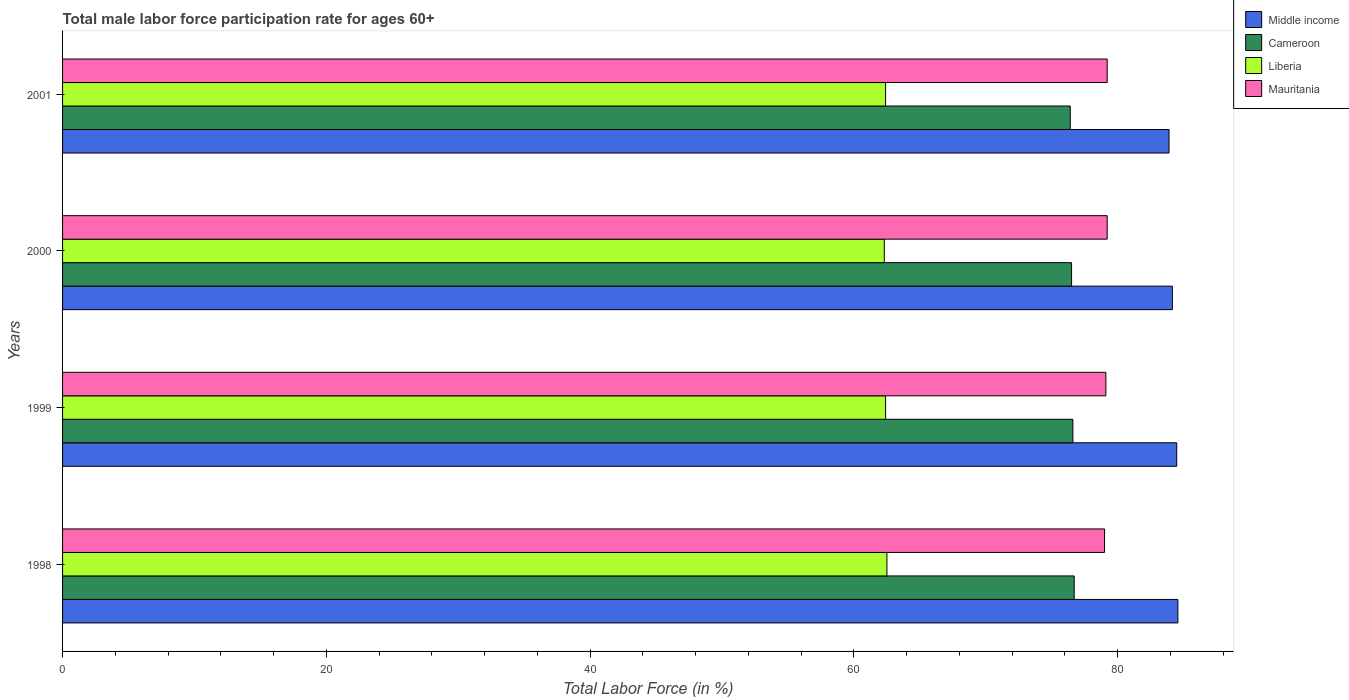Are the number of bars per tick equal to the number of legend labels?
Your answer should be very brief. Yes. What is the label of the 2nd group of bars from the top?
Your answer should be compact. 2000. What is the male labor force participation rate in Cameroon in 1999?
Make the answer very short. 76.6. Across all years, what is the maximum male labor force participation rate in Cameroon?
Your answer should be very brief. 76.7. Across all years, what is the minimum male labor force participation rate in Cameroon?
Provide a succinct answer. 76.4. In which year was the male labor force participation rate in Middle income maximum?
Your answer should be very brief. 1998. In which year was the male labor force participation rate in Middle income minimum?
Make the answer very short. 2001. What is the total male labor force participation rate in Middle income in the graph?
Give a very brief answer. 337.07. What is the difference between the male labor force participation rate in Liberia in 1998 and that in 2000?
Your answer should be very brief. 0.2. What is the difference between the male labor force participation rate in Middle income in 2000 and the male labor force participation rate in Mauritania in 1999?
Provide a succinct answer. 5.04. What is the average male labor force participation rate in Mauritania per year?
Provide a succinct answer. 79.12. In the year 1998, what is the difference between the male labor force participation rate in Liberia and male labor force participation rate in Cameroon?
Offer a very short reply. -14.2. In how many years, is the male labor force participation rate in Middle income greater than 20 %?
Give a very brief answer. 4. What is the ratio of the male labor force participation rate in Liberia in 1998 to that in 2000?
Ensure brevity in your answer.  1. What is the difference between the highest and the second highest male labor force participation rate in Cameroon?
Your answer should be compact. 0.1. What is the difference between the highest and the lowest male labor force participation rate in Mauritania?
Your answer should be compact. 0.2. Is it the case that in every year, the sum of the male labor force participation rate in Cameroon and male labor force participation rate in Middle income is greater than the sum of male labor force participation rate in Mauritania and male labor force participation rate in Liberia?
Give a very brief answer. Yes. What does the 2nd bar from the bottom in 1998 represents?
Your answer should be compact. Cameroon. Is it the case that in every year, the sum of the male labor force participation rate in Liberia and male labor force participation rate in Cameroon is greater than the male labor force participation rate in Middle income?
Your answer should be compact. Yes. How many bars are there?
Give a very brief answer. 16. Are all the bars in the graph horizontal?
Keep it short and to the point. Yes. How many years are there in the graph?
Your response must be concise. 4. What is the difference between two consecutive major ticks on the X-axis?
Provide a short and direct response. 20. Does the graph contain any zero values?
Provide a short and direct response. No. Does the graph contain grids?
Your answer should be compact. No. How many legend labels are there?
Ensure brevity in your answer.  4. What is the title of the graph?
Provide a succinct answer. Total male labor force participation rate for ages 60+. What is the label or title of the X-axis?
Offer a terse response. Total Labor Force (in %). What is the label or title of the Y-axis?
Keep it short and to the point. Years. What is the Total Labor Force (in %) of Middle income in 1998?
Offer a very short reply. 84.56. What is the Total Labor Force (in %) in Cameroon in 1998?
Ensure brevity in your answer.  76.7. What is the Total Labor Force (in %) of Liberia in 1998?
Offer a very short reply. 62.5. What is the Total Labor Force (in %) of Mauritania in 1998?
Your response must be concise. 79. What is the Total Labor Force (in %) in Middle income in 1999?
Offer a very short reply. 84.47. What is the Total Labor Force (in %) of Cameroon in 1999?
Keep it short and to the point. 76.6. What is the Total Labor Force (in %) in Liberia in 1999?
Keep it short and to the point. 62.4. What is the Total Labor Force (in %) of Mauritania in 1999?
Your response must be concise. 79.1. What is the Total Labor Force (in %) in Middle income in 2000?
Provide a short and direct response. 84.14. What is the Total Labor Force (in %) of Cameroon in 2000?
Offer a terse response. 76.5. What is the Total Labor Force (in %) in Liberia in 2000?
Your answer should be compact. 62.3. What is the Total Labor Force (in %) of Mauritania in 2000?
Provide a short and direct response. 79.2. What is the Total Labor Force (in %) in Middle income in 2001?
Ensure brevity in your answer.  83.89. What is the Total Labor Force (in %) of Cameroon in 2001?
Ensure brevity in your answer.  76.4. What is the Total Labor Force (in %) of Liberia in 2001?
Offer a terse response. 62.4. What is the Total Labor Force (in %) of Mauritania in 2001?
Keep it short and to the point. 79.2. Across all years, what is the maximum Total Labor Force (in %) in Middle income?
Your answer should be very brief. 84.56. Across all years, what is the maximum Total Labor Force (in %) of Cameroon?
Your answer should be compact. 76.7. Across all years, what is the maximum Total Labor Force (in %) in Liberia?
Offer a very short reply. 62.5. Across all years, what is the maximum Total Labor Force (in %) of Mauritania?
Ensure brevity in your answer.  79.2. Across all years, what is the minimum Total Labor Force (in %) in Middle income?
Keep it short and to the point. 83.89. Across all years, what is the minimum Total Labor Force (in %) in Cameroon?
Provide a short and direct response. 76.4. Across all years, what is the minimum Total Labor Force (in %) of Liberia?
Give a very brief answer. 62.3. Across all years, what is the minimum Total Labor Force (in %) in Mauritania?
Offer a very short reply. 79. What is the total Total Labor Force (in %) in Middle income in the graph?
Your answer should be compact. 337.07. What is the total Total Labor Force (in %) of Cameroon in the graph?
Provide a succinct answer. 306.2. What is the total Total Labor Force (in %) in Liberia in the graph?
Make the answer very short. 249.6. What is the total Total Labor Force (in %) in Mauritania in the graph?
Keep it short and to the point. 316.5. What is the difference between the Total Labor Force (in %) in Middle income in 1998 and that in 1999?
Your answer should be very brief. 0.09. What is the difference between the Total Labor Force (in %) in Cameroon in 1998 and that in 1999?
Give a very brief answer. 0.1. What is the difference between the Total Labor Force (in %) of Middle income in 1998 and that in 2000?
Ensure brevity in your answer.  0.42. What is the difference between the Total Labor Force (in %) in Cameroon in 1998 and that in 2000?
Your answer should be very brief. 0.2. What is the difference between the Total Labor Force (in %) of Middle income in 1998 and that in 2001?
Your answer should be compact. 0.67. What is the difference between the Total Labor Force (in %) in Liberia in 1998 and that in 2001?
Offer a terse response. 0.1. What is the difference between the Total Labor Force (in %) in Mauritania in 1998 and that in 2001?
Your response must be concise. -0.2. What is the difference between the Total Labor Force (in %) of Middle income in 1999 and that in 2000?
Make the answer very short. 0.33. What is the difference between the Total Labor Force (in %) of Middle income in 1999 and that in 2001?
Provide a succinct answer. 0.58. What is the difference between the Total Labor Force (in %) in Cameroon in 1999 and that in 2001?
Your response must be concise. 0.2. What is the difference between the Total Labor Force (in %) of Liberia in 1999 and that in 2001?
Give a very brief answer. 0. What is the difference between the Total Labor Force (in %) in Mauritania in 1999 and that in 2001?
Provide a short and direct response. -0.1. What is the difference between the Total Labor Force (in %) of Middle income in 2000 and that in 2001?
Give a very brief answer. 0.25. What is the difference between the Total Labor Force (in %) in Liberia in 2000 and that in 2001?
Your response must be concise. -0.1. What is the difference between the Total Labor Force (in %) of Mauritania in 2000 and that in 2001?
Your answer should be compact. 0. What is the difference between the Total Labor Force (in %) in Middle income in 1998 and the Total Labor Force (in %) in Cameroon in 1999?
Give a very brief answer. 7.96. What is the difference between the Total Labor Force (in %) of Middle income in 1998 and the Total Labor Force (in %) of Liberia in 1999?
Provide a short and direct response. 22.16. What is the difference between the Total Labor Force (in %) in Middle income in 1998 and the Total Labor Force (in %) in Mauritania in 1999?
Your response must be concise. 5.46. What is the difference between the Total Labor Force (in %) in Cameroon in 1998 and the Total Labor Force (in %) in Liberia in 1999?
Your answer should be very brief. 14.3. What is the difference between the Total Labor Force (in %) of Cameroon in 1998 and the Total Labor Force (in %) of Mauritania in 1999?
Your response must be concise. -2.4. What is the difference between the Total Labor Force (in %) of Liberia in 1998 and the Total Labor Force (in %) of Mauritania in 1999?
Offer a terse response. -16.6. What is the difference between the Total Labor Force (in %) in Middle income in 1998 and the Total Labor Force (in %) in Cameroon in 2000?
Provide a short and direct response. 8.06. What is the difference between the Total Labor Force (in %) in Middle income in 1998 and the Total Labor Force (in %) in Liberia in 2000?
Offer a very short reply. 22.26. What is the difference between the Total Labor Force (in %) of Middle income in 1998 and the Total Labor Force (in %) of Mauritania in 2000?
Offer a terse response. 5.36. What is the difference between the Total Labor Force (in %) of Cameroon in 1998 and the Total Labor Force (in %) of Liberia in 2000?
Provide a succinct answer. 14.4. What is the difference between the Total Labor Force (in %) in Cameroon in 1998 and the Total Labor Force (in %) in Mauritania in 2000?
Keep it short and to the point. -2.5. What is the difference between the Total Labor Force (in %) of Liberia in 1998 and the Total Labor Force (in %) of Mauritania in 2000?
Make the answer very short. -16.7. What is the difference between the Total Labor Force (in %) in Middle income in 1998 and the Total Labor Force (in %) in Cameroon in 2001?
Keep it short and to the point. 8.16. What is the difference between the Total Labor Force (in %) of Middle income in 1998 and the Total Labor Force (in %) of Liberia in 2001?
Make the answer very short. 22.16. What is the difference between the Total Labor Force (in %) of Middle income in 1998 and the Total Labor Force (in %) of Mauritania in 2001?
Your answer should be very brief. 5.36. What is the difference between the Total Labor Force (in %) in Cameroon in 1998 and the Total Labor Force (in %) in Mauritania in 2001?
Your answer should be compact. -2.5. What is the difference between the Total Labor Force (in %) of Liberia in 1998 and the Total Labor Force (in %) of Mauritania in 2001?
Your answer should be compact. -16.7. What is the difference between the Total Labor Force (in %) in Middle income in 1999 and the Total Labor Force (in %) in Cameroon in 2000?
Your response must be concise. 7.97. What is the difference between the Total Labor Force (in %) in Middle income in 1999 and the Total Labor Force (in %) in Liberia in 2000?
Offer a very short reply. 22.17. What is the difference between the Total Labor Force (in %) in Middle income in 1999 and the Total Labor Force (in %) in Mauritania in 2000?
Offer a very short reply. 5.27. What is the difference between the Total Labor Force (in %) in Cameroon in 1999 and the Total Labor Force (in %) in Liberia in 2000?
Your answer should be very brief. 14.3. What is the difference between the Total Labor Force (in %) in Liberia in 1999 and the Total Labor Force (in %) in Mauritania in 2000?
Offer a terse response. -16.8. What is the difference between the Total Labor Force (in %) in Middle income in 1999 and the Total Labor Force (in %) in Cameroon in 2001?
Your answer should be very brief. 8.07. What is the difference between the Total Labor Force (in %) of Middle income in 1999 and the Total Labor Force (in %) of Liberia in 2001?
Keep it short and to the point. 22.07. What is the difference between the Total Labor Force (in %) in Middle income in 1999 and the Total Labor Force (in %) in Mauritania in 2001?
Your answer should be compact. 5.27. What is the difference between the Total Labor Force (in %) in Liberia in 1999 and the Total Labor Force (in %) in Mauritania in 2001?
Offer a very short reply. -16.8. What is the difference between the Total Labor Force (in %) in Middle income in 2000 and the Total Labor Force (in %) in Cameroon in 2001?
Make the answer very short. 7.74. What is the difference between the Total Labor Force (in %) of Middle income in 2000 and the Total Labor Force (in %) of Liberia in 2001?
Give a very brief answer. 21.74. What is the difference between the Total Labor Force (in %) of Middle income in 2000 and the Total Labor Force (in %) of Mauritania in 2001?
Provide a short and direct response. 4.94. What is the difference between the Total Labor Force (in %) in Cameroon in 2000 and the Total Labor Force (in %) in Mauritania in 2001?
Offer a very short reply. -2.7. What is the difference between the Total Labor Force (in %) in Liberia in 2000 and the Total Labor Force (in %) in Mauritania in 2001?
Your response must be concise. -16.9. What is the average Total Labor Force (in %) in Middle income per year?
Provide a short and direct response. 84.27. What is the average Total Labor Force (in %) of Cameroon per year?
Offer a terse response. 76.55. What is the average Total Labor Force (in %) of Liberia per year?
Ensure brevity in your answer.  62.4. What is the average Total Labor Force (in %) in Mauritania per year?
Give a very brief answer. 79.12. In the year 1998, what is the difference between the Total Labor Force (in %) in Middle income and Total Labor Force (in %) in Cameroon?
Keep it short and to the point. 7.86. In the year 1998, what is the difference between the Total Labor Force (in %) of Middle income and Total Labor Force (in %) of Liberia?
Provide a succinct answer. 22.06. In the year 1998, what is the difference between the Total Labor Force (in %) in Middle income and Total Labor Force (in %) in Mauritania?
Provide a short and direct response. 5.56. In the year 1998, what is the difference between the Total Labor Force (in %) in Cameroon and Total Labor Force (in %) in Liberia?
Provide a succinct answer. 14.2. In the year 1998, what is the difference between the Total Labor Force (in %) of Cameroon and Total Labor Force (in %) of Mauritania?
Provide a succinct answer. -2.3. In the year 1998, what is the difference between the Total Labor Force (in %) of Liberia and Total Labor Force (in %) of Mauritania?
Your response must be concise. -16.5. In the year 1999, what is the difference between the Total Labor Force (in %) of Middle income and Total Labor Force (in %) of Cameroon?
Make the answer very short. 7.87. In the year 1999, what is the difference between the Total Labor Force (in %) of Middle income and Total Labor Force (in %) of Liberia?
Keep it short and to the point. 22.07. In the year 1999, what is the difference between the Total Labor Force (in %) of Middle income and Total Labor Force (in %) of Mauritania?
Your response must be concise. 5.37. In the year 1999, what is the difference between the Total Labor Force (in %) of Cameroon and Total Labor Force (in %) of Mauritania?
Your response must be concise. -2.5. In the year 1999, what is the difference between the Total Labor Force (in %) in Liberia and Total Labor Force (in %) in Mauritania?
Your answer should be compact. -16.7. In the year 2000, what is the difference between the Total Labor Force (in %) of Middle income and Total Labor Force (in %) of Cameroon?
Offer a very short reply. 7.64. In the year 2000, what is the difference between the Total Labor Force (in %) of Middle income and Total Labor Force (in %) of Liberia?
Provide a short and direct response. 21.84. In the year 2000, what is the difference between the Total Labor Force (in %) of Middle income and Total Labor Force (in %) of Mauritania?
Keep it short and to the point. 4.94. In the year 2000, what is the difference between the Total Labor Force (in %) of Liberia and Total Labor Force (in %) of Mauritania?
Offer a very short reply. -16.9. In the year 2001, what is the difference between the Total Labor Force (in %) of Middle income and Total Labor Force (in %) of Cameroon?
Provide a short and direct response. 7.49. In the year 2001, what is the difference between the Total Labor Force (in %) of Middle income and Total Labor Force (in %) of Liberia?
Keep it short and to the point. 21.49. In the year 2001, what is the difference between the Total Labor Force (in %) of Middle income and Total Labor Force (in %) of Mauritania?
Offer a very short reply. 4.69. In the year 2001, what is the difference between the Total Labor Force (in %) of Cameroon and Total Labor Force (in %) of Liberia?
Your response must be concise. 14. In the year 2001, what is the difference between the Total Labor Force (in %) in Cameroon and Total Labor Force (in %) in Mauritania?
Provide a succinct answer. -2.8. In the year 2001, what is the difference between the Total Labor Force (in %) of Liberia and Total Labor Force (in %) of Mauritania?
Provide a short and direct response. -16.8. What is the ratio of the Total Labor Force (in %) in Liberia in 1998 to that in 1999?
Your response must be concise. 1. What is the ratio of the Total Labor Force (in %) in Cameroon in 1998 to that in 2000?
Provide a short and direct response. 1. What is the ratio of the Total Labor Force (in %) in Liberia in 1998 to that in 2000?
Provide a short and direct response. 1. What is the ratio of the Total Labor Force (in %) in Cameroon in 1999 to that in 2000?
Your answer should be compact. 1. What is the ratio of the Total Labor Force (in %) in Liberia in 1999 to that in 2000?
Offer a terse response. 1. What is the ratio of the Total Labor Force (in %) of Mauritania in 1999 to that in 2000?
Your response must be concise. 1. What is the ratio of the Total Labor Force (in %) in Middle income in 1999 to that in 2001?
Your answer should be very brief. 1.01. What is the ratio of the Total Labor Force (in %) in Cameroon in 1999 to that in 2001?
Give a very brief answer. 1. What is the ratio of the Total Labor Force (in %) in Liberia in 1999 to that in 2001?
Provide a short and direct response. 1. What is the ratio of the Total Labor Force (in %) in Middle income in 2000 to that in 2001?
Ensure brevity in your answer.  1. What is the difference between the highest and the second highest Total Labor Force (in %) of Middle income?
Offer a terse response. 0.09. What is the difference between the highest and the second highest Total Labor Force (in %) of Cameroon?
Your answer should be very brief. 0.1. What is the difference between the highest and the second highest Total Labor Force (in %) of Mauritania?
Keep it short and to the point. 0. What is the difference between the highest and the lowest Total Labor Force (in %) in Middle income?
Your answer should be compact. 0.67. What is the difference between the highest and the lowest Total Labor Force (in %) of Cameroon?
Provide a succinct answer. 0.3. 